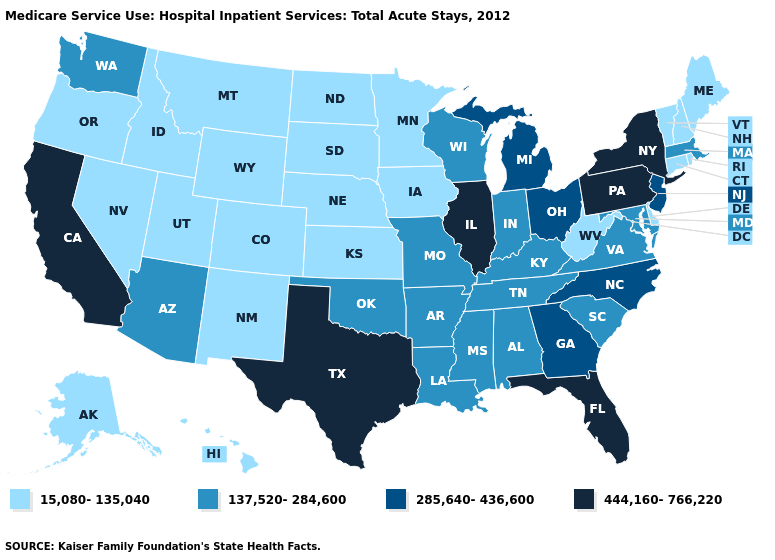Name the states that have a value in the range 137,520-284,600?
Quick response, please. Alabama, Arizona, Arkansas, Indiana, Kentucky, Louisiana, Maryland, Massachusetts, Mississippi, Missouri, Oklahoma, South Carolina, Tennessee, Virginia, Washington, Wisconsin. What is the value of Wyoming?
Answer briefly. 15,080-135,040. Does California have a higher value than New Hampshire?
Give a very brief answer. Yes. Name the states that have a value in the range 444,160-766,220?
Give a very brief answer. California, Florida, Illinois, New York, Pennsylvania, Texas. Does the first symbol in the legend represent the smallest category?
Give a very brief answer. Yes. Name the states that have a value in the range 444,160-766,220?
Be succinct. California, Florida, Illinois, New York, Pennsylvania, Texas. What is the value of Delaware?
Be succinct. 15,080-135,040. What is the lowest value in the USA?
Give a very brief answer. 15,080-135,040. Does Pennsylvania have the highest value in the USA?
Be succinct. Yes. What is the value of Kentucky?
Keep it brief. 137,520-284,600. Which states have the highest value in the USA?
Keep it brief. California, Florida, Illinois, New York, Pennsylvania, Texas. Among the states that border Kentucky , which have the lowest value?
Give a very brief answer. West Virginia. Does Vermont have the same value as Minnesota?
Be succinct. Yes. Which states hav the highest value in the MidWest?
Short answer required. Illinois. Which states have the lowest value in the South?
Keep it brief. Delaware, West Virginia. 